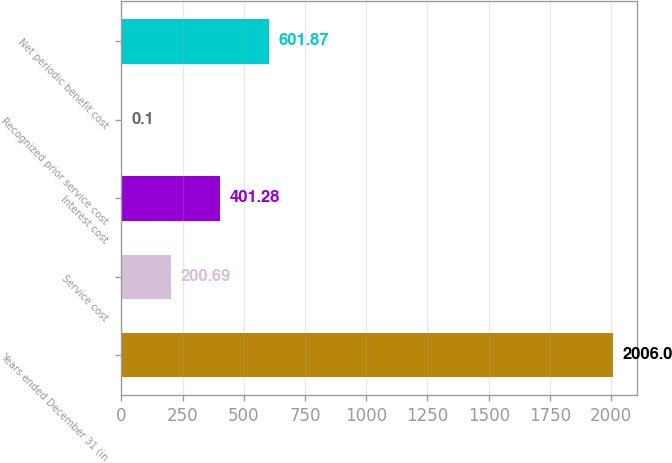<chart> <loc_0><loc_0><loc_500><loc_500><bar_chart><fcel>Years ended December 31 (in<fcel>Service cost<fcel>Interest cost<fcel>Recognized prior service cost<fcel>Net periodic benefit cost<nl><fcel>2006<fcel>200.69<fcel>401.28<fcel>0.1<fcel>601.87<nl></chart> 